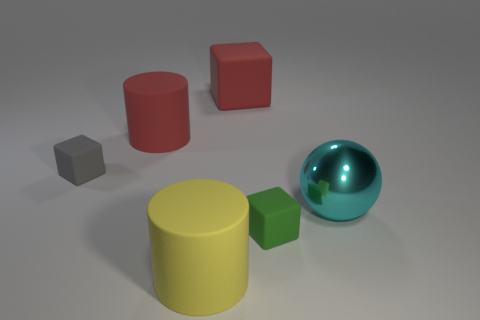Add 3 yellow things. How many objects exist? 9 Subtract all cylinders. How many objects are left? 4 Add 1 metal objects. How many metal objects exist? 2 Subtract 1 red cylinders. How many objects are left? 5 Subtract all yellow things. Subtract all large cyan balls. How many objects are left? 4 Add 4 large things. How many large things are left? 8 